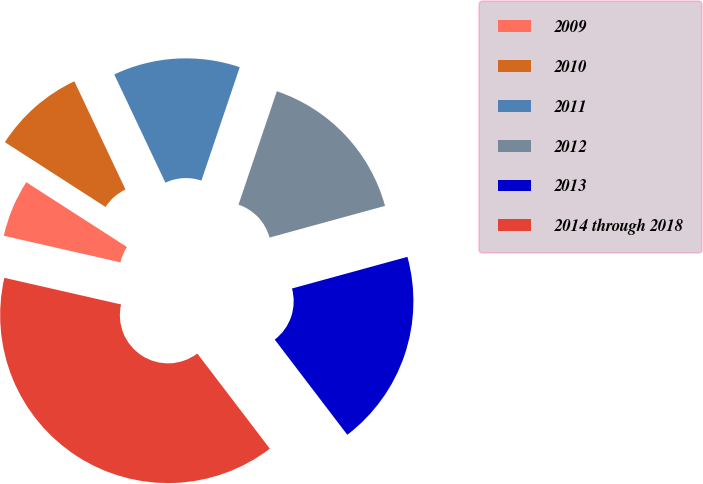Convert chart to OTSL. <chart><loc_0><loc_0><loc_500><loc_500><pie_chart><fcel>2009<fcel>2010<fcel>2011<fcel>2012<fcel>2013<fcel>2014 through 2018<nl><fcel>5.53%<fcel>8.87%<fcel>12.21%<fcel>15.55%<fcel>18.89%<fcel>38.93%<nl></chart> 